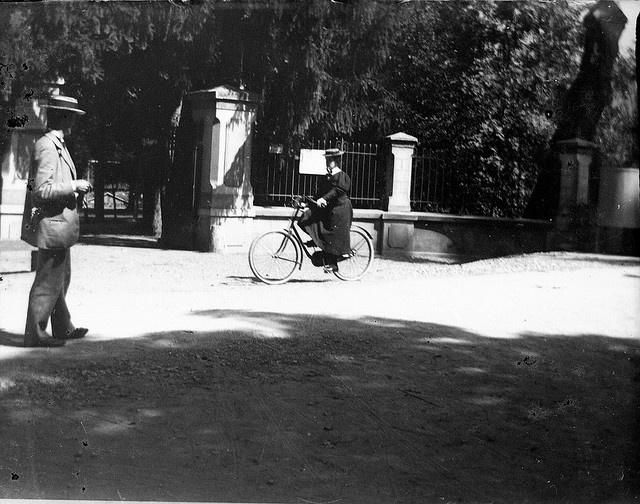Describe the objects in this image and their specific colors. I can see people in black, gray, lightgray, and darkgray tones, bicycle in black, lightgray, darkgray, and gray tones, people in black, gray, lightgray, and darkgray tones, and tie in black, lightgray, gray, and darkgray tones in this image. 